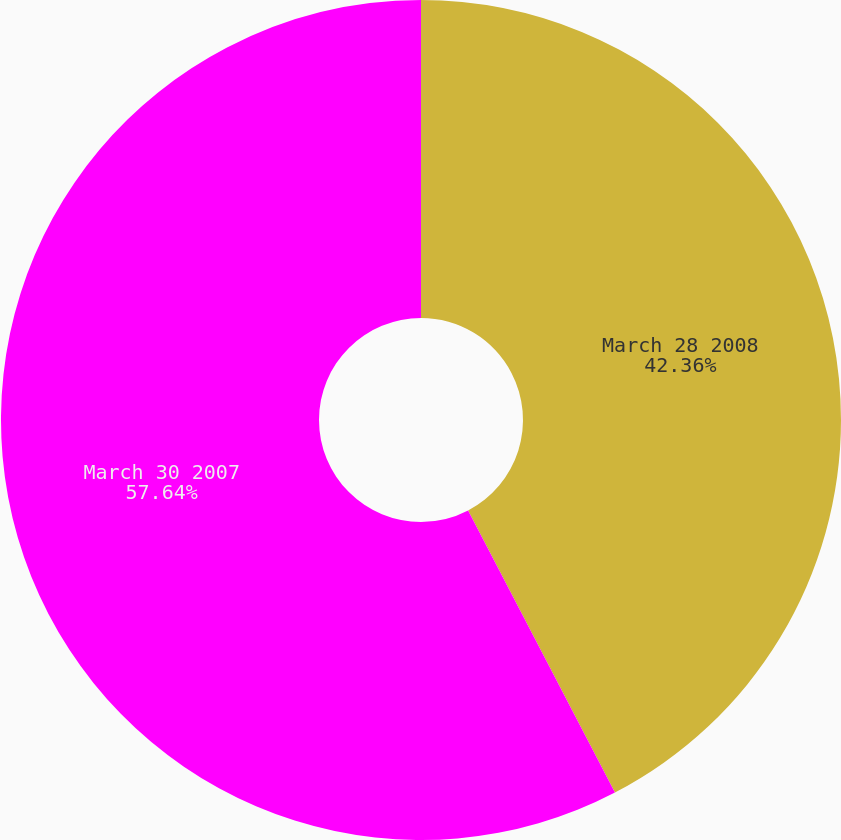Convert chart. <chart><loc_0><loc_0><loc_500><loc_500><pie_chart><fcel>March 28 2008<fcel>March 30 2007<nl><fcel>42.36%<fcel>57.64%<nl></chart> 